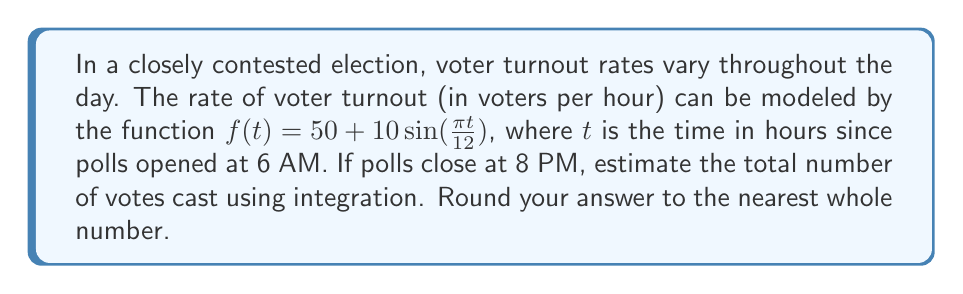Show me your answer to this math problem. Let's approach this step-by-step:

1) First, we need to set up our integral. The total number of votes will be the integral of the voter turnout rate over the time period the polls are open.

2) The polls are open from 6 AM to 8 PM, which is a 14-hour period. We'll integrate from $t=0$ to $t=14$.

3) Our integral is:

   $$\int_0^{14} (50 + 10\sin(\frac{\pi t}{12})) dt$$

4) Let's integrate this:
   
   $$\int_0^{14} 50 dt + \int_0^{14} 10\sin(\frac{\pi t}{12}) dt$$

5) The first part is straightforward:
   
   $$50t|_0^{14} = 50(14) - 50(0) = 700$$

6) For the second part, we use the substitution $u = \frac{\pi t}{12}$:
   
   $$\frac{120}{\pi} \int_0^{\frac{14\pi}{12}} \sin(u) du$$

7) This evaluates to:

   $$\frac{120}{\pi} [-\cos(u)]_0^{\frac{14\pi}{12}} = \frac{120}{\pi} [-\cos(\frac{14\pi}{12}) + \cos(0)]$$

8) Simplifying:

   $$\frac{120}{\pi} [-\cos(\frac{7\pi}{6}) + 1] \approx 19.10$$

9) Adding the results from steps 5 and 8:

   $$700 + 19.10 = 719.10$$

10) Rounding to the nearest whole number:

    $$719$$
Answer: 719 votes 